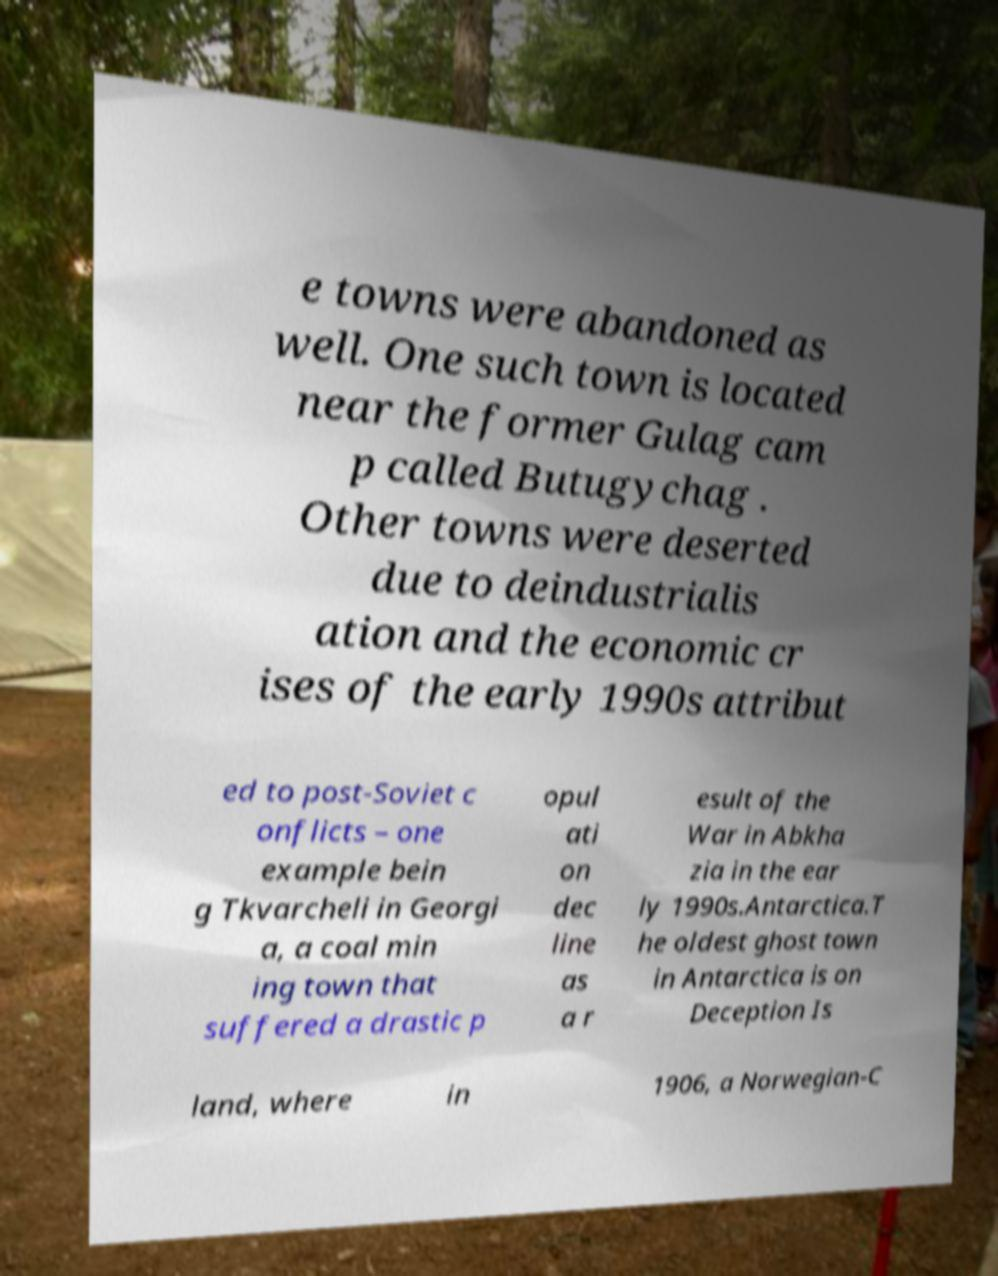I need the written content from this picture converted into text. Can you do that? e towns were abandoned as well. One such town is located near the former Gulag cam p called Butugychag . Other towns were deserted due to deindustrialis ation and the economic cr ises of the early 1990s attribut ed to post-Soviet c onflicts – one example bein g Tkvarcheli in Georgi a, a coal min ing town that suffered a drastic p opul ati on dec line as a r esult of the War in Abkha zia in the ear ly 1990s.Antarctica.T he oldest ghost town in Antarctica is on Deception Is land, where in 1906, a Norwegian-C 